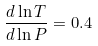Convert formula to latex. <formula><loc_0><loc_0><loc_500><loc_500>\frac { d \ln T } { d \ln P } = 0 . 4</formula> 